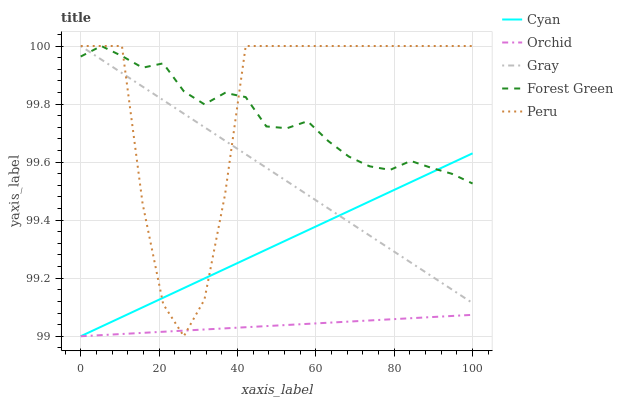Does Orchid have the minimum area under the curve?
Answer yes or no. Yes. Does Peru have the maximum area under the curve?
Answer yes or no. Yes. Does Gray have the minimum area under the curve?
Answer yes or no. No. Does Gray have the maximum area under the curve?
Answer yes or no. No. Is Gray the smoothest?
Answer yes or no. Yes. Is Peru the roughest?
Answer yes or no. Yes. Is Forest Green the smoothest?
Answer yes or no. No. Is Forest Green the roughest?
Answer yes or no. No. Does Cyan have the lowest value?
Answer yes or no. Yes. Does Gray have the lowest value?
Answer yes or no. No. Does Peru have the highest value?
Answer yes or no. Yes. Does Orchid have the highest value?
Answer yes or no. No. Is Orchid less than Forest Green?
Answer yes or no. Yes. Is Gray greater than Orchid?
Answer yes or no. Yes. Does Gray intersect Cyan?
Answer yes or no. Yes. Is Gray less than Cyan?
Answer yes or no. No. Is Gray greater than Cyan?
Answer yes or no. No. Does Orchid intersect Forest Green?
Answer yes or no. No. 